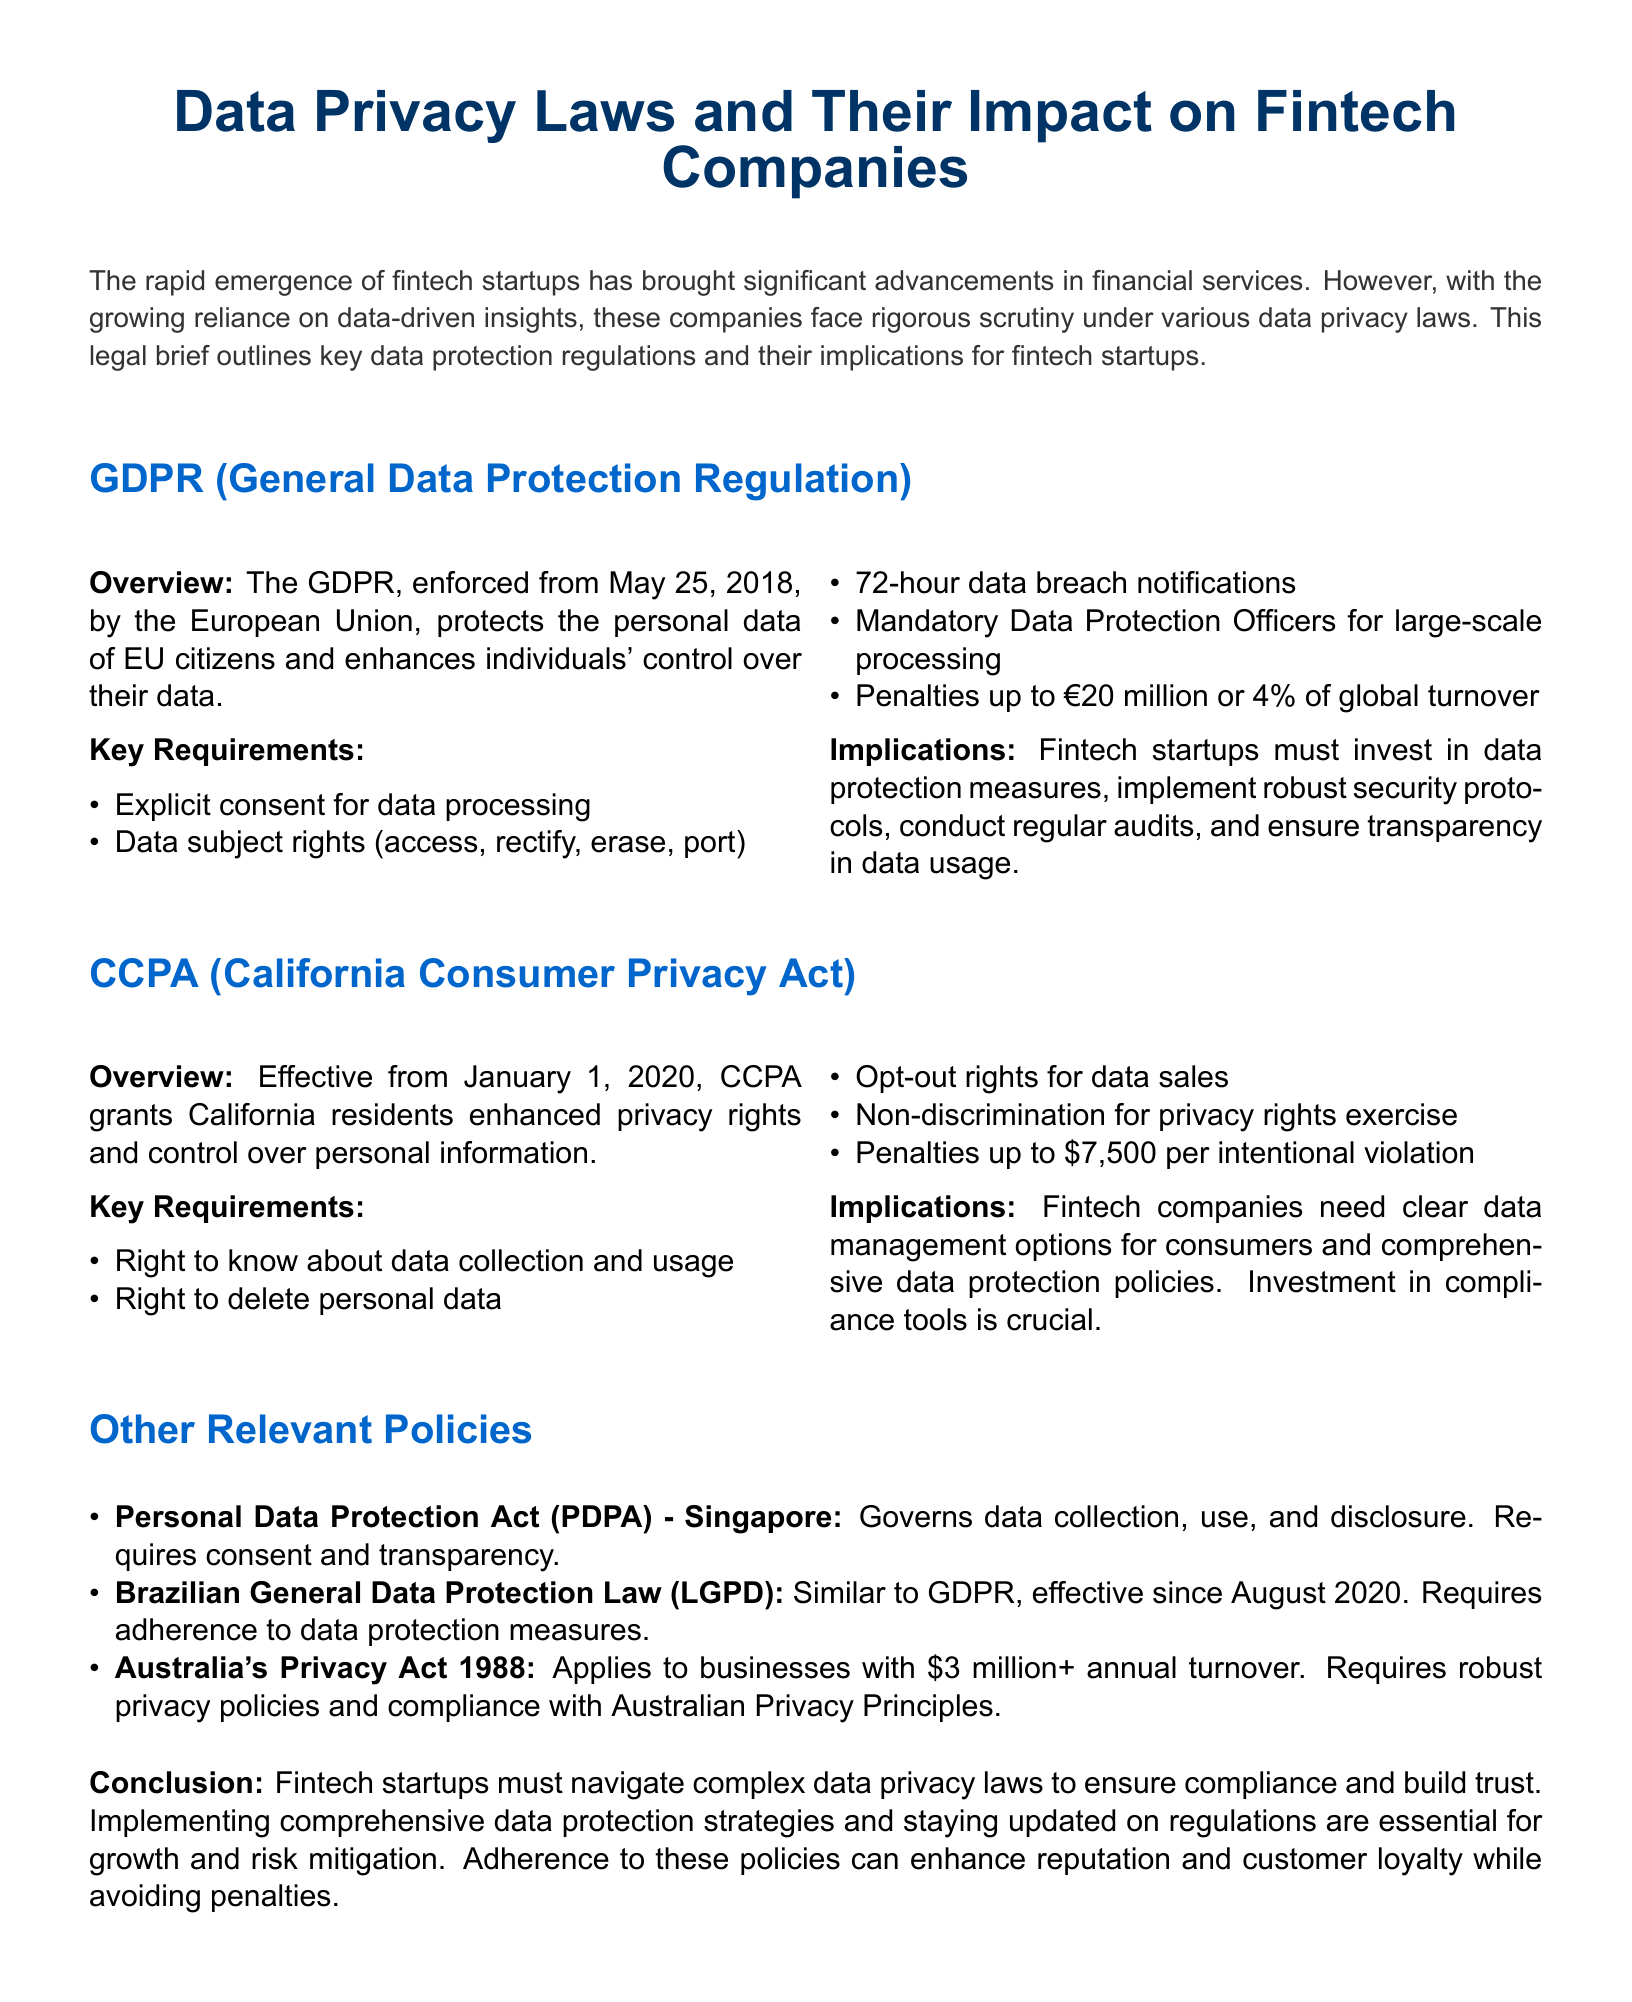What is the full name of GDPR? GDPR stands for General Data Protection Regulation.
Answer: General Data Protection Regulation When was GDPR enforced? The document states that GDPR was enforced from May 25, 2018.
Answer: May 25, 2018 What is the maximum penalty for GDPR violations? The document specifies that penalties can be up to €20 million or 4% of global turnover.
Answer: €20 million or 4% of global turnover What rights do consumers have under CCPA? The document lists the right to know about data collection and usage as one of the rights under CCPA.
Answer: Right to know about data collection and usage What is the effective date of CCPA? The effective date of CCPA mentioned in the document is January 1, 2020.
Answer: January 1, 2020 Which law governs data protection in Brazil? The document refers to the Brazilian General Data Protection Law.
Answer: Brazilian General Data Protection Law What is one implication for fintech companies under GDPR? The document mentions that fintech startups must invest in data protection measures.
Answer: Invest in data protection measures What is a requirement of the Personal Data Protection Act in Singapore? The requirement mentioned is that it governs data collection, use, and disclosure with an emphasis on consent.
Answer: Consent What might comprehensive data protection strategies enhance according to the conclusion? The conclusion indicates that comprehensive data protection strategies can enhance reputation.
Answer: Reputation 